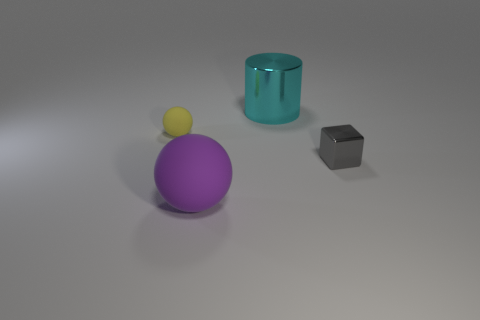Add 3 red rubber blocks. How many objects exist? 7 Subtract all cylinders. How many objects are left? 3 Add 1 metal things. How many metal things are left? 3 Add 1 purple cylinders. How many purple cylinders exist? 1 Subtract 0 green cylinders. How many objects are left? 4 Subtract all matte things. Subtract all purple rubber things. How many objects are left? 1 